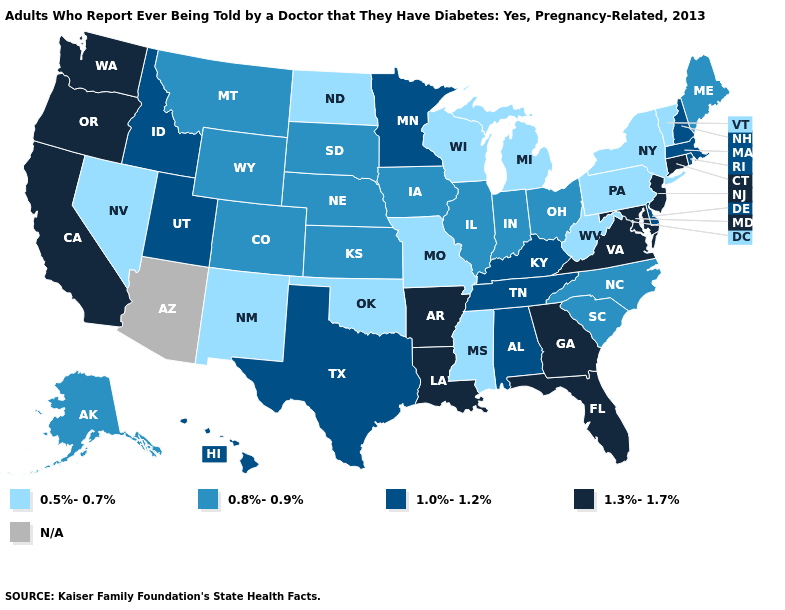Does Florida have the highest value in the USA?
Answer briefly. Yes. Name the states that have a value in the range 0.8%-0.9%?
Write a very short answer. Alaska, Colorado, Illinois, Indiana, Iowa, Kansas, Maine, Montana, Nebraska, North Carolina, Ohio, South Carolina, South Dakota, Wyoming. Among the states that border Rhode Island , which have the highest value?
Give a very brief answer. Connecticut. Does Missouri have the lowest value in the MidWest?
Short answer required. Yes. Among the states that border Nebraska , does Missouri have the lowest value?
Answer briefly. Yes. Among the states that border West Virginia , which have the lowest value?
Quick response, please. Pennsylvania. Name the states that have a value in the range 1.3%-1.7%?
Concise answer only. Arkansas, California, Connecticut, Florida, Georgia, Louisiana, Maryland, New Jersey, Oregon, Virginia, Washington. Does the map have missing data?
Quick response, please. Yes. Does California have the highest value in the West?
Keep it brief. Yes. Does Nevada have the lowest value in the West?
Quick response, please. Yes. What is the highest value in the USA?
Quick response, please. 1.3%-1.7%. Among the states that border New Mexico , does Texas have the lowest value?
Give a very brief answer. No. Name the states that have a value in the range N/A?
Keep it brief. Arizona. Name the states that have a value in the range 0.8%-0.9%?
Write a very short answer. Alaska, Colorado, Illinois, Indiana, Iowa, Kansas, Maine, Montana, Nebraska, North Carolina, Ohio, South Carolina, South Dakota, Wyoming. Does the map have missing data?
Concise answer only. Yes. 